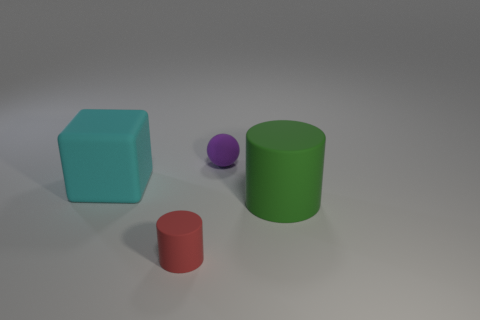Add 3 red cylinders. How many objects exist? 7 Subtract all spheres. How many objects are left? 3 Add 3 big cyan matte things. How many big cyan matte things are left? 4 Add 1 small cyan metal cylinders. How many small cyan metal cylinders exist? 1 Subtract 0 yellow cylinders. How many objects are left? 4 Subtract all green balls. Subtract all blue cylinders. How many balls are left? 1 Subtract all big matte cylinders. Subtract all tiny purple matte objects. How many objects are left? 2 